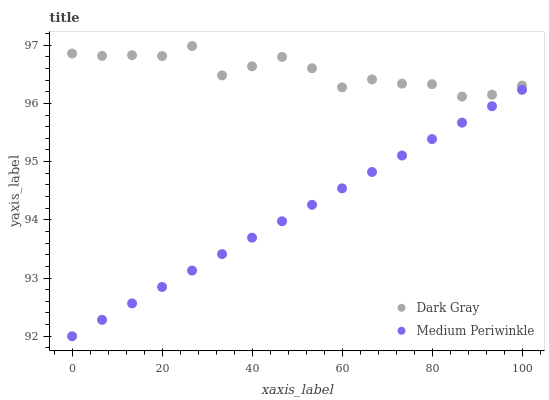Does Medium Periwinkle have the minimum area under the curve?
Answer yes or no. Yes. Does Dark Gray have the maximum area under the curve?
Answer yes or no. Yes. Does Medium Periwinkle have the maximum area under the curve?
Answer yes or no. No. Is Medium Periwinkle the smoothest?
Answer yes or no. Yes. Is Dark Gray the roughest?
Answer yes or no. Yes. Is Medium Periwinkle the roughest?
Answer yes or no. No. Does Medium Periwinkle have the lowest value?
Answer yes or no. Yes. Does Dark Gray have the highest value?
Answer yes or no. Yes. Does Medium Periwinkle have the highest value?
Answer yes or no. No. Is Medium Periwinkle less than Dark Gray?
Answer yes or no. Yes. Is Dark Gray greater than Medium Periwinkle?
Answer yes or no. Yes. Does Medium Periwinkle intersect Dark Gray?
Answer yes or no. No. 